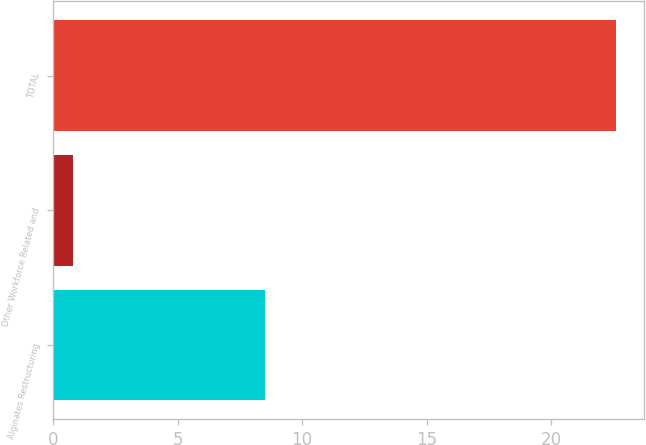Convert chart. <chart><loc_0><loc_0><loc_500><loc_500><bar_chart><fcel>Alginates Restructuring<fcel>Other Workforce Related and<fcel>TOTAL<nl><fcel>8.5<fcel>0.8<fcel>22.6<nl></chart> 